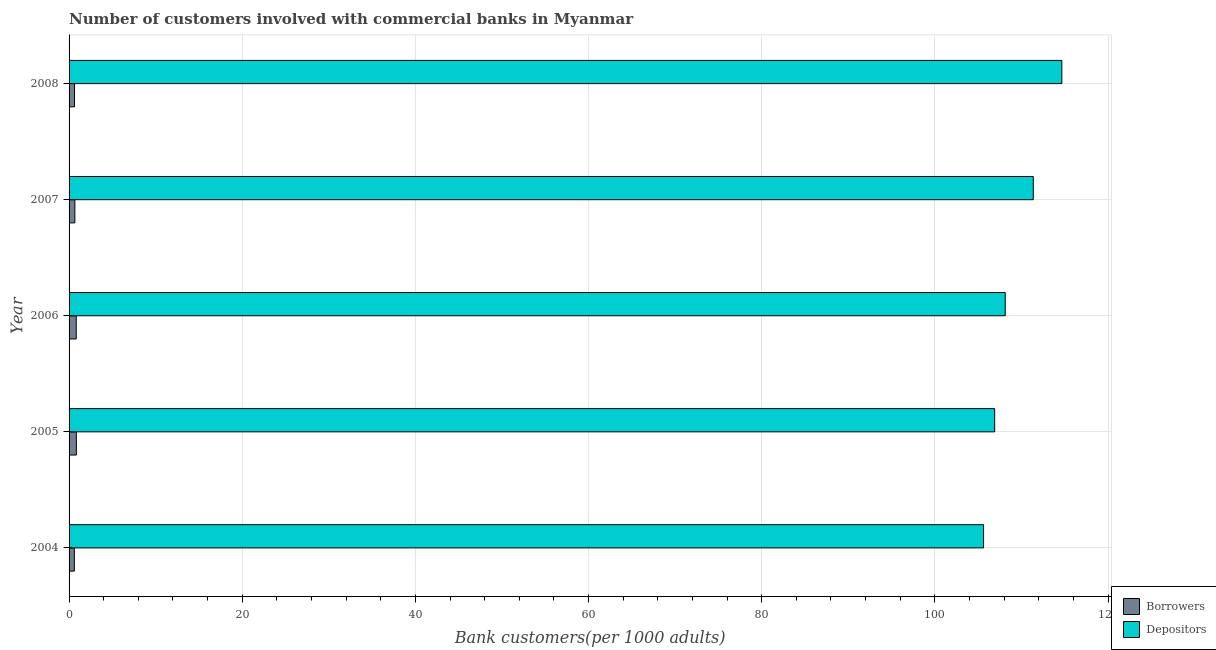How many bars are there on the 4th tick from the top?
Give a very brief answer. 2. What is the label of the 3rd group of bars from the top?
Give a very brief answer. 2006. In how many cases, is the number of bars for a given year not equal to the number of legend labels?
Offer a very short reply. 0. What is the number of borrowers in 2007?
Your answer should be very brief. 0.67. Across all years, what is the maximum number of borrowers?
Provide a short and direct response. 0.84. Across all years, what is the minimum number of depositors?
Provide a succinct answer. 105.62. In which year was the number of borrowers minimum?
Keep it short and to the point. 2004. What is the total number of borrowers in the graph?
Provide a short and direct response. 3.57. What is the difference between the number of depositors in 2004 and that in 2006?
Your answer should be very brief. -2.5. What is the difference between the number of borrowers in 2008 and the number of depositors in 2004?
Provide a succinct answer. -105. What is the average number of depositors per year?
Provide a succinct answer. 109.34. In the year 2004, what is the difference between the number of borrowers and number of depositors?
Make the answer very short. -105.01. What is the ratio of the number of borrowers in 2004 to that in 2005?
Your response must be concise. 0.72. Is the difference between the number of borrowers in 2006 and 2008 greater than the difference between the number of depositors in 2006 and 2008?
Give a very brief answer. Yes. What is the difference between the highest and the second highest number of depositors?
Offer a terse response. 3.3. What is the difference between the highest and the lowest number of borrowers?
Give a very brief answer. 0.23. What does the 2nd bar from the top in 2004 represents?
Give a very brief answer. Borrowers. What does the 2nd bar from the bottom in 2005 represents?
Your response must be concise. Depositors. How many bars are there?
Provide a short and direct response. 10. Are all the bars in the graph horizontal?
Offer a very short reply. Yes. How many years are there in the graph?
Provide a succinct answer. 5. What is the difference between two consecutive major ticks on the X-axis?
Offer a terse response. 20. Are the values on the major ticks of X-axis written in scientific E-notation?
Ensure brevity in your answer.  No. Does the graph contain grids?
Give a very brief answer. Yes. How many legend labels are there?
Provide a short and direct response. 2. What is the title of the graph?
Provide a short and direct response. Number of customers involved with commercial banks in Myanmar. Does "Banks" appear as one of the legend labels in the graph?
Offer a terse response. No. What is the label or title of the X-axis?
Your response must be concise. Bank customers(per 1000 adults). What is the Bank customers(per 1000 adults) of Borrowers in 2004?
Give a very brief answer. 0.61. What is the Bank customers(per 1000 adults) in Depositors in 2004?
Offer a very short reply. 105.62. What is the Bank customers(per 1000 adults) in Borrowers in 2005?
Give a very brief answer. 0.84. What is the Bank customers(per 1000 adults) in Depositors in 2005?
Offer a terse response. 106.9. What is the Bank customers(per 1000 adults) in Borrowers in 2006?
Your answer should be compact. 0.83. What is the Bank customers(per 1000 adults) of Depositors in 2006?
Your answer should be very brief. 108.13. What is the Bank customers(per 1000 adults) in Borrowers in 2007?
Offer a very short reply. 0.67. What is the Bank customers(per 1000 adults) in Depositors in 2007?
Your response must be concise. 111.37. What is the Bank customers(per 1000 adults) in Borrowers in 2008?
Your answer should be compact. 0.63. What is the Bank customers(per 1000 adults) in Depositors in 2008?
Keep it short and to the point. 114.66. Across all years, what is the maximum Bank customers(per 1000 adults) in Borrowers?
Provide a short and direct response. 0.84. Across all years, what is the maximum Bank customers(per 1000 adults) in Depositors?
Your answer should be compact. 114.66. Across all years, what is the minimum Bank customers(per 1000 adults) in Borrowers?
Provide a short and direct response. 0.61. Across all years, what is the minimum Bank customers(per 1000 adults) of Depositors?
Give a very brief answer. 105.62. What is the total Bank customers(per 1000 adults) in Borrowers in the graph?
Provide a short and direct response. 3.57. What is the total Bank customers(per 1000 adults) of Depositors in the graph?
Provide a succinct answer. 546.68. What is the difference between the Bank customers(per 1000 adults) in Borrowers in 2004 and that in 2005?
Offer a very short reply. -0.23. What is the difference between the Bank customers(per 1000 adults) in Depositors in 2004 and that in 2005?
Keep it short and to the point. -1.28. What is the difference between the Bank customers(per 1000 adults) of Borrowers in 2004 and that in 2006?
Provide a short and direct response. -0.22. What is the difference between the Bank customers(per 1000 adults) in Depositors in 2004 and that in 2006?
Give a very brief answer. -2.5. What is the difference between the Bank customers(per 1000 adults) of Borrowers in 2004 and that in 2007?
Keep it short and to the point. -0.06. What is the difference between the Bank customers(per 1000 adults) of Depositors in 2004 and that in 2007?
Your response must be concise. -5.74. What is the difference between the Bank customers(per 1000 adults) of Borrowers in 2004 and that in 2008?
Your response must be concise. -0.02. What is the difference between the Bank customers(per 1000 adults) of Depositors in 2004 and that in 2008?
Provide a succinct answer. -9.04. What is the difference between the Bank customers(per 1000 adults) of Borrowers in 2005 and that in 2006?
Provide a short and direct response. 0.01. What is the difference between the Bank customers(per 1000 adults) in Depositors in 2005 and that in 2006?
Your answer should be very brief. -1.22. What is the difference between the Bank customers(per 1000 adults) of Borrowers in 2005 and that in 2007?
Keep it short and to the point. 0.17. What is the difference between the Bank customers(per 1000 adults) of Depositors in 2005 and that in 2007?
Keep it short and to the point. -4.46. What is the difference between the Bank customers(per 1000 adults) in Borrowers in 2005 and that in 2008?
Keep it short and to the point. 0.22. What is the difference between the Bank customers(per 1000 adults) of Depositors in 2005 and that in 2008?
Ensure brevity in your answer.  -7.76. What is the difference between the Bank customers(per 1000 adults) of Borrowers in 2006 and that in 2007?
Offer a very short reply. 0.16. What is the difference between the Bank customers(per 1000 adults) of Depositors in 2006 and that in 2007?
Ensure brevity in your answer.  -3.24. What is the difference between the Bank customers(per 1000 adults) of Borrowers in 2006 and that in 2008?
Offer a terse response. 0.2. What is the difference between the Bank customers(per 1000 adults) of Depositors in 2006 and that in 2008?
Your response must be concise. -6.54. What is the difference between the Bank customers(per 1000 adults) of Borrowers in 2007 and that in 2008?
Offer a terse response. 0.04. What is the difference between the Bank customers(per 1000 adults) in Depositors in 2007 and that in 2008?
Your answer should be very brief. -3.3. What is the difference between the Bank customers(per 1000 adults) in Borrowers in 2004 and the Bank customers(per 1000 adults) in Depositors in 2005?
Give a very brief answer. -106.29. What is the difference between the Bank customers(per 1000 adults) in Borrowers in 2004 and the Bank customers(per 1000 adults) in Depositors in 2006?
Offer a terse response. -107.52. What is the difference between the Bank customers(per 1000 adults) in Borrowers in 2004 and the Bank customers(per 1000 adults) in Depositors in 2007?
Your response must be concise. -110.76. What is the difference between the Bank customers(per 1000 adults) in Borrowers in 2004 and the Bank customers(per 1000 adults) in Depositors in 2008?
Your answer should be very brief. -114.05. What is the difference between the Bank customers(per 1000 adults) in Borrowers in 2005 and the Bank customers(per 1000 adults) in Depositors in 2006?
Offer a terse response. -107.28. What is the difference between the Bank customers(per 1000 adults) in Borrowers in 2005 and the Bank customers(per 1000 adults) in Depositors in 2007?
Offer a terse response. -110.52. What is the difference between the Bank customers(per 1000 adults) of Borrowers in 2005 and the Bank customers(per 1000 adults) of Depositors in 2008?
Your answer should be compact. -113.82. What is the difference between the Bank customers(per 1000 adults) in Borrowers in 2006 and the Bank customers(per 1000 adults) in Depositors in 2007?
Give a very brief answer. -110.54. What is the difference between the Bank customers(per 1000 adults) of Borrowers in 2006 and the Bank customers(per 1000 adults) of Depositors in 2008?
Your response must be concise. -113.84. What is the difference between the Bank customers(per 1000 adults) of Borrowers in 2007 and the Bank customers(per 1000 adults) of Depositors in 2008?
Your answer should be compact. -114. What is the average Bank customers(per 1000 adults) in Borrowers per year?
Your answer should be compact. 0.71. What is the average Bank customers(per 1000 adults) of Depositors per year?
Offer a very short reply. 109.34. In the year 2004, what is the difference between the Bank customers(per 1000 adults) in Borrowers and Bank customers(per 1000 adults) in Depositors?
Your response must be concise. -105.01. In the year 2005, what is the difference between the Bank customers(per 1000 adults) of Borrowers and Bank customers(per 1000 adults) of Depositors?
Offer a very short reply. -106.06. In the year 2006, what is the difference between the Bank customers(per 1000 adults) in Borrowers and Bank customers(per 1000 adults) in Depositors?
Give a very brief answer. -107.3. In the year 2007, what is the difference between the Bank customers(per 1000 adults) in Borrowers and Bank customers(per 1000 adults) in Depositors?
Make the answer very short. -110.7. In the year 2008, what is the difference between the Bank customers(per 1000 adults) of Borrowers and Bank customers(per 1000 adults) of Depositors?
Your response must be concise. -114.04. What is the ratio of the Bank customers(per 1000 adults) of Borrowers in 2004 to that in 2005?
Ensure brevity in your answer.  0.72. What is the ratio of the Bank customers(per 1000 adults) in Depositors in 2004 to that in 2005?
Make the answer very short. 0.99. What is the ratio of the Bank customers(per 1000 adults) of Borrowers in 2004 to that in 2006?
Provide a succinct answer. 0.74. What is the ratio of the Bank customers(per 1000 adults) of Depositors in 2004 to that in 2006?
Your answer should be very brief. 0.98. What is the ratio of the Bank customers(per 1000 adults) of Borrowers in 2004 to that in 2007?
Make the answer very short. 0.91. What is the ratio of the Bank customers(per 1000 adults) of Depositors in 2004 to that in 2007?
Your answer should be compact. 0.95. What is the ratio of the Bank customers(per 1000 adults) in Borrowers in 2004 to that in 2008?
Ensure brevity in your answer.  0.97. What is the ratio of the Bank customers(per 1000 adults) of Depositors in 2004 to that in 2008?
Offer a terse response. 0.92. What is the ratio of the Bank customers(per 1000 adults) in Borrowers in 2005 to that in 2006?
Your response must be concise. 1.02. What is the ratio of the Bank customers(per 1000 adults) of Depositors in 2005 to that in 2006?
Offer a terse response. 0.99. What is the ratio of the Bank customers(per 1000 adults) of Borrowers in 2005 to that in 2007?
Your answer should be compact. 1.26. What is the ratio of the Bank customers(per 1000 adults) of Depositors in 2005 to that in 2007?
Your answer should be very brief. 0.96. What is the ratio of the Bank customers(per 1000 adults) in Borrowers in 2005 to that in 2008?
Your answer should be very brief. 1.34. What is the ratio of the Bank customers(per 1000 adults) of Depositors in 2005 to that in 2008?
Give a very brief answer. 0.93. What is the ratio of the Bank customers(per 1000 adults) of Borrowers in 2006 to that in 2007?
Provide a succinct answer. 1.24. What is the ratio of the Bank customers(per 1000 adults) of Depositors in 2006 to that in 2007?
Your answer should be very brief. 0.97. What is the ratio of the Bank customers(per 1000 adults) of Borrowers in 2006 to that in 2008?
Ensure brevity in your answer.  1.32. What is the ratio of the Bank customers(per 1000 adults) of Depositors in 2006 to that in 2008?
Provide a short and direct response. 0.94. What is the ratio of the Bank customers(per 1000 adults) in Borrowers in 2007 to that in 2008?
Offer a very short reply. 1.07. What is the ratio of the Bank customers(per 1000 adults) in Depositors in 2007 to that in 2008?
Your response must be concise. 0.97. What is the difference between the highest and the second highest Bank customers(per 1000 adults) in Borrowers?
Your answer should be compact. 0.01. What is the difference between the highest and the second highest Bank customers(per 1000 adults) of Depositors?
Provide a succinct answer. 3.3. What is the difference between the highest and the lowest Bank customers(per 1000 adults) in Borrowers?
Provide a succinct answer. 0.23. What is the difference between the highest and the lowest Bank customers(per 1000 adults) in Depositors?
Ensure brevity in your answer.  9.04. 